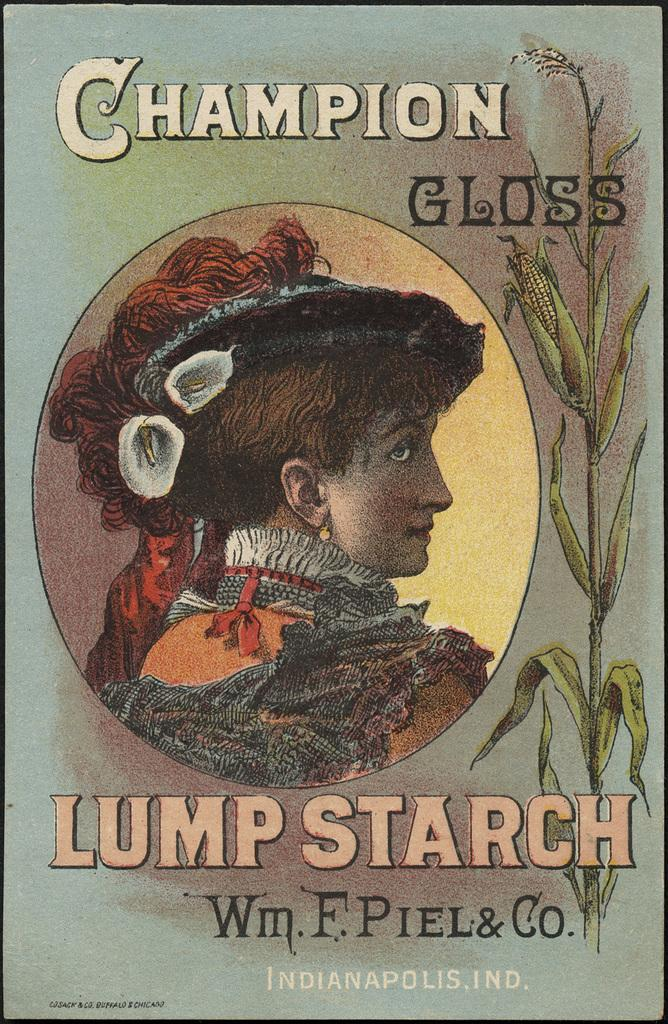<image>
Write a terse but informative summary of the picture. poster for champion gloss lump starch that has picture of woman in victorian era clothing 